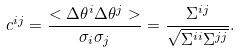Convert formula to latex. <formula><loc_0><loc_0><loc_500><loc_500>c ^ { i j } = \frac { < \Delta \theta ^ { i } \Delta \theta ^ { j } > } { \sigma _ { i } \sigma _ { j } } = \frac { \Sigma ^ { i j } } { \sqrt { \Sigma ^ { i i } \Sigma ^ { j j } } } .</formula> 